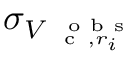<formula> <loc_0><loc_0><loc_500><loc_500>\sigma _ { V _ { c , r _ { i } } ^ { o b s } }</formula> 